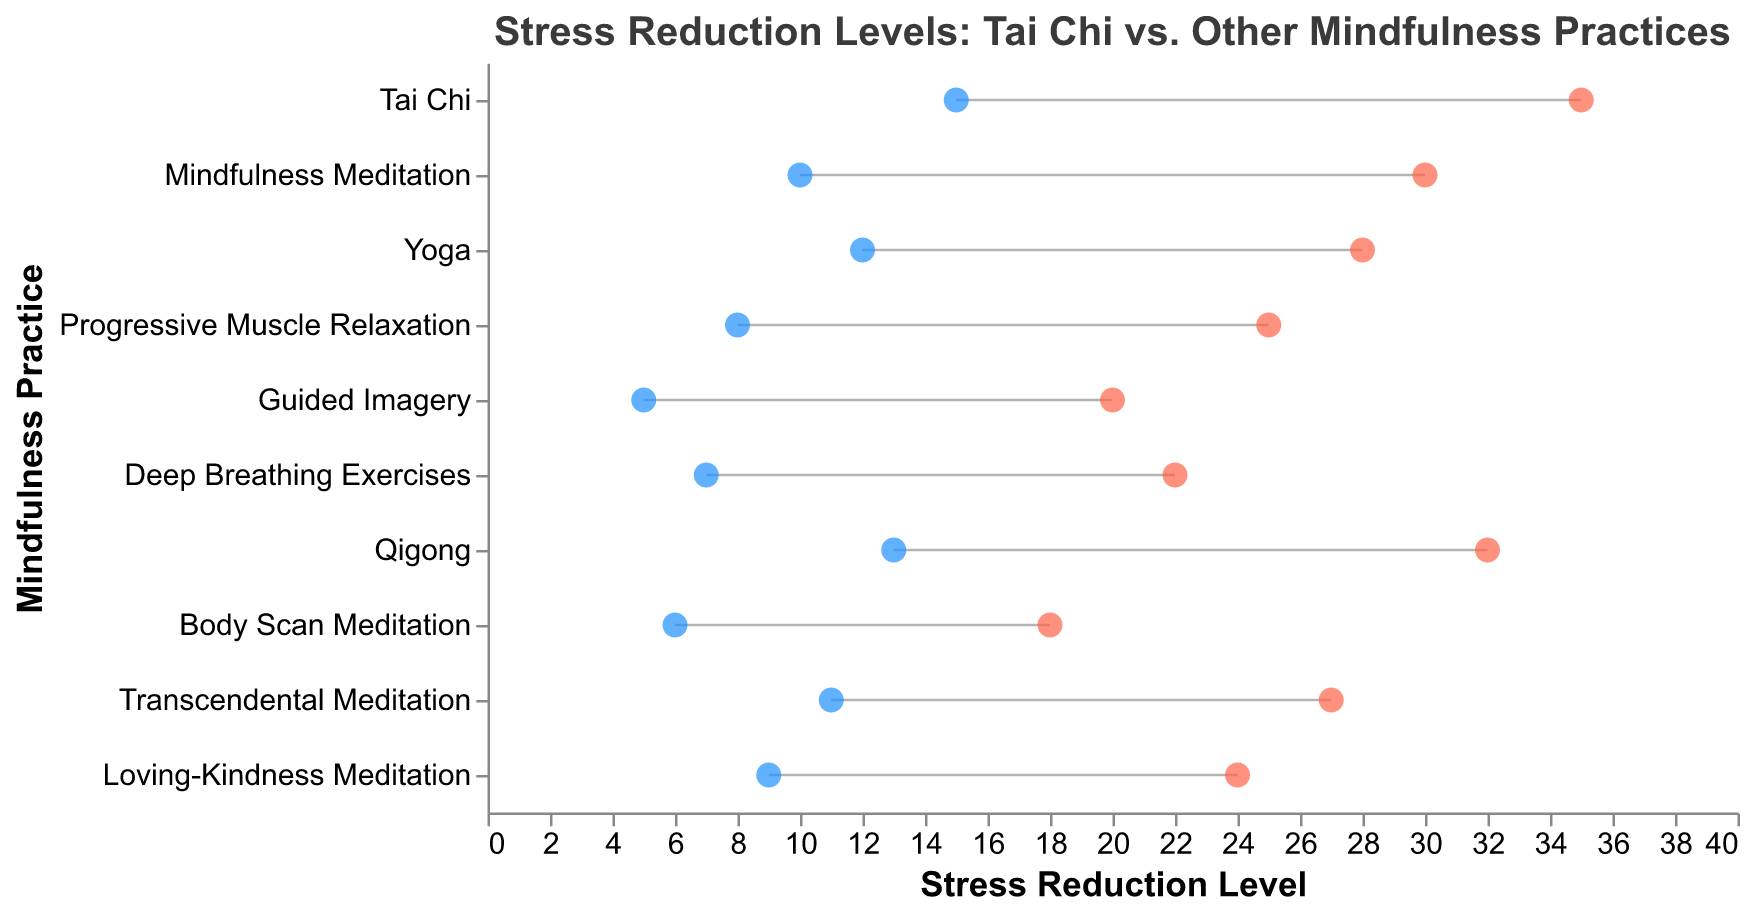What is the title of the figure? The title of the figure is placed at the top and usually represents a brief description of the content being visualized. Here, the title indicates a comparison of stress reduction levels between Tai Chi and other mindfulness practices.
Answer: Stress Reduction Levels: Tai Chi vs. Other Mindfulness Practices Which mindfulness practice shows the highest maximum stress reduction level? By looking at the red dots (indicating the maximum stress reduction level) and identifying which practice has its red dot farthest to the right, we see that Tai Chi has the highest maximum stress reduction level.
Answer: Tai Chi What is the minimum stress reduction level for Progressive Muscle Relaxation? The blue dots on the plot represent the minimum stress reduction levels. By locating the dot for Progressive Muscle Relaxation, we see that the minimum level is marked at 8.
Answer: 8 How many practices have a minimum stress reduction level less than 10? We need to count the number of practices where the blue dot (minimum stress reduction) is located to the left of the value 10 on the x-axis. Body Scan Meditation, Guided Imagery, Deep Breathing Exercises, Progressive Muscle Relaxation, and Loving-Kindness Meditation all have minimum levels below 10. So, there are 5 such practices.
Answer: 5 What is the range of stress reduction for Tai Chi? The range is calculated by subtracting the minimum value from the maximum value. For Tai Chi, the maximum is 35 and the minimum is 15. Therefore, the range is 35 - 15 = 20.
Answer: 20 Which practice shows the second highest maximum stress reduction level? By identifying the second farthest red dot to the right, we see that Qigong has the second highest maximum stress reduction level at 32, after Tai Chi (35).
Answer: Qigong What are the average stress reduction levels for Deep Breathing Exercises and Guided Imagery? The average is the sum of the minimum and maximum values divided by 2. For Deep Breathing Exercises: (7 + 22) / 2 = 14.5. For Guided Imagery: (5 + 20) / 2 = 12.5.
Answer: Deep Breathing Exercises: 14.5, Guided Imagery: 12.5 Which practice has a wider range of stress reduction: Yoga or Loving-Kindness Meditation? The range is calculated by subtracting the minimum from the maximum. For Yoga: 28 - 12 = 16. For Loving-Kindness Meditation: 24 - 9 = 15. Thus, Yoga has a wider range.
Answer: Yoga Are the minimum and maximum stress reduction levels of Tai Chi higher than those of Body Scan Meditation? For Tai Chi, the minimum is 15 and maximum is 35. For Body Scan Meditation, the minimum is 6 and maximum is 18. Both the minimum and maximum stress reduction levels of Tai Chi are higher than those of Body Scan Meditation.
Answer: Yes Which mindfulness practice has the smallest difference between its minimum and maximum stress reduction levels? The difference between the maximum and minimum values for each practice needs to be calculated. Body Scan Meditation has the smallest difference: 18 - 6 = 12.
Answer: Body Scan Meditation 